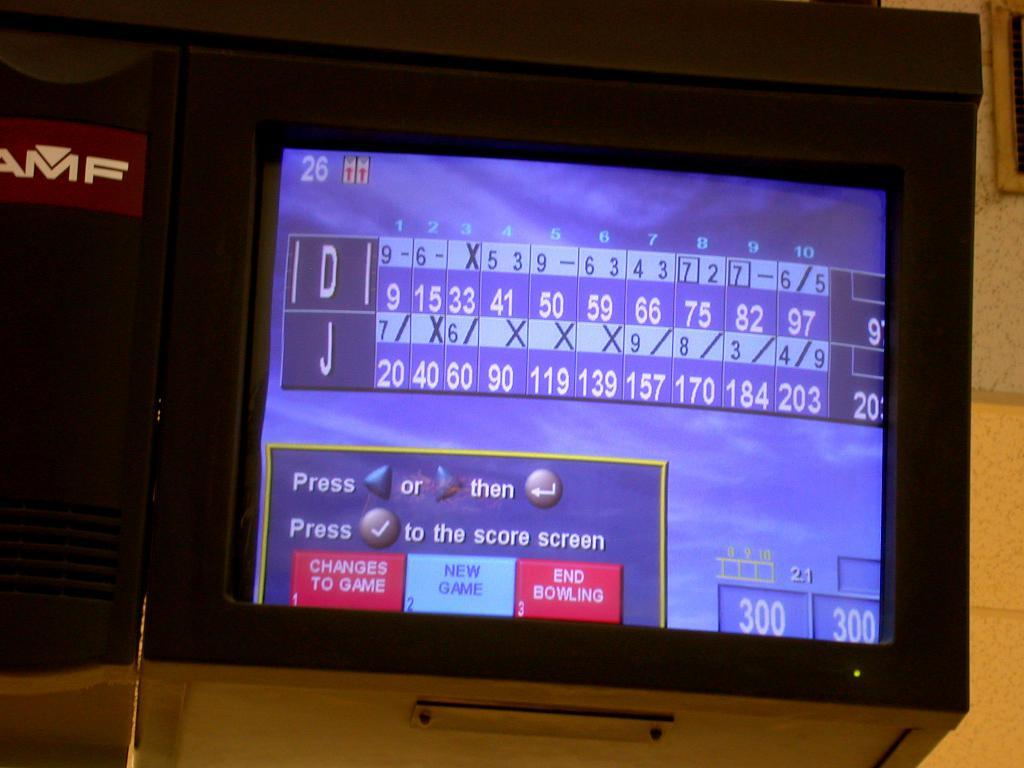<image>
Provide a brief description of the given image. A screen shows that "D" and "J" are competing in a game of bowling. 